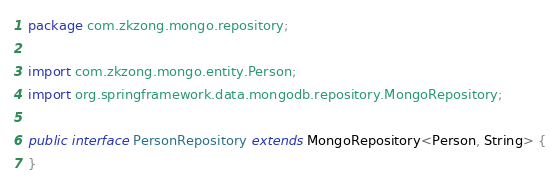Convert code to text. <code><loc_0><loc_0><loc_500><loc_500><_Java_>package com.zkzong.mongo.repository;

import com.zkzong.mongo.entity.Person;
import org.springframework.data.mongodb.repository.MongoRepository;

public interface PersonRepository extends MongoRepository<Person, String> {
}
</code> 